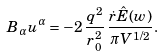Convert formula to latex. <formula><loc_0><loc_0><loc_500><loc_500>B _ { \alpha } u ^ { \alpha } = - 2 \, \frac { q ^ { 2 } } { r _ { 0 } ^ { 2 } } \, \frac { \dot { r } \hat { E } ( w ) } { \pi V ^ { 1 / 2 } } .</formula> 